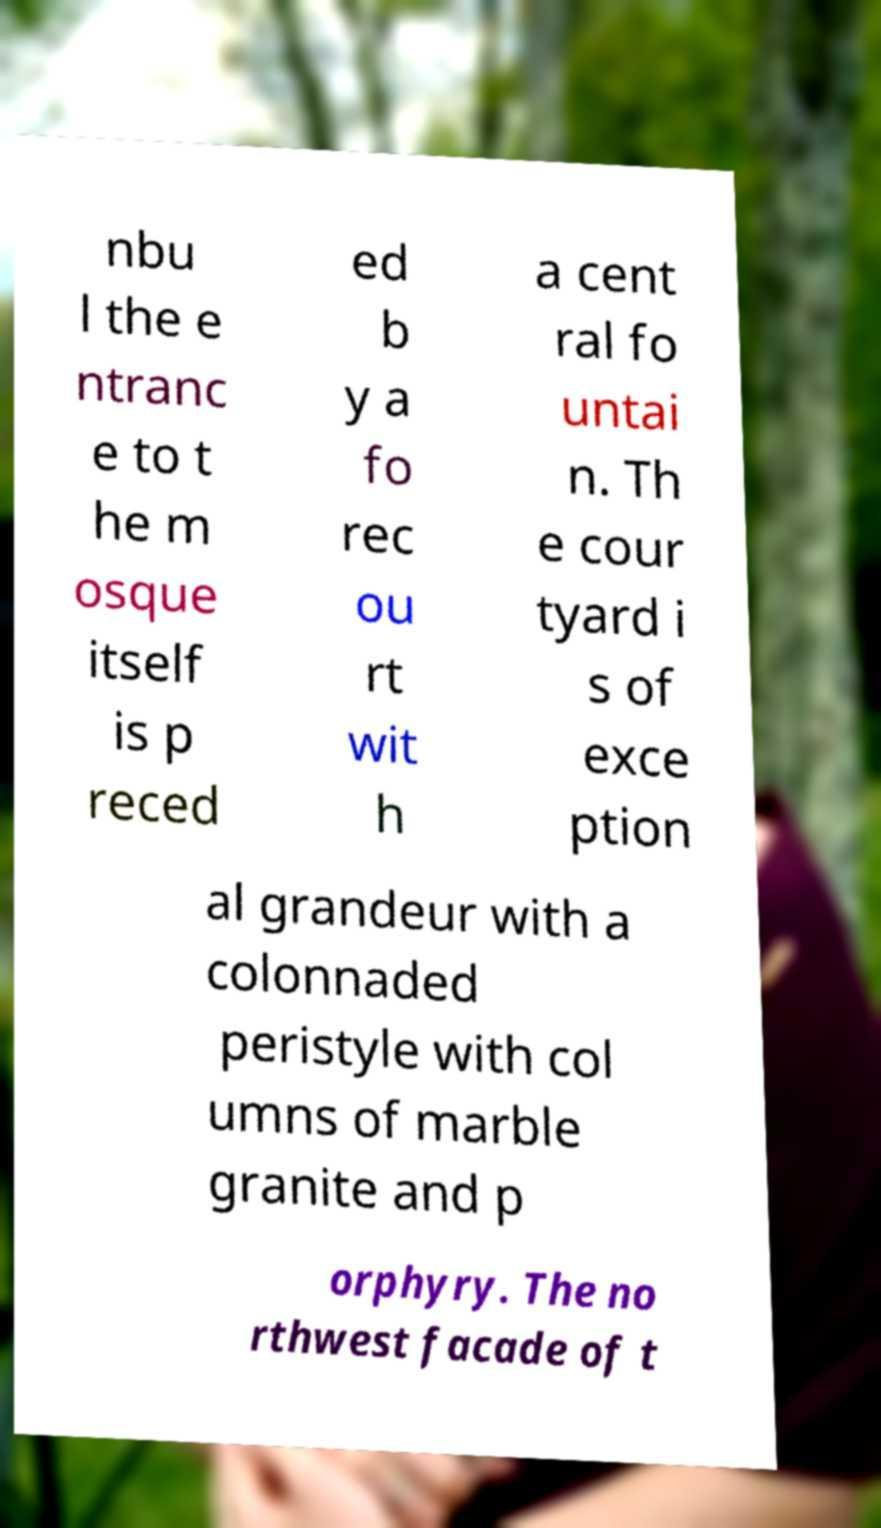What messages or text are displayed in this image? I need them in a readable, typed format. nbu l the e ntranc e to t he m osque itself is p reced ed b y a fo rec ou rt wit h a cent ral fo untai n. Th e cour tyard i s of exce ption al grandeur with a colonnaded peristyle with col umns of marble granite and p orphyry. The no rthwest facade of t 